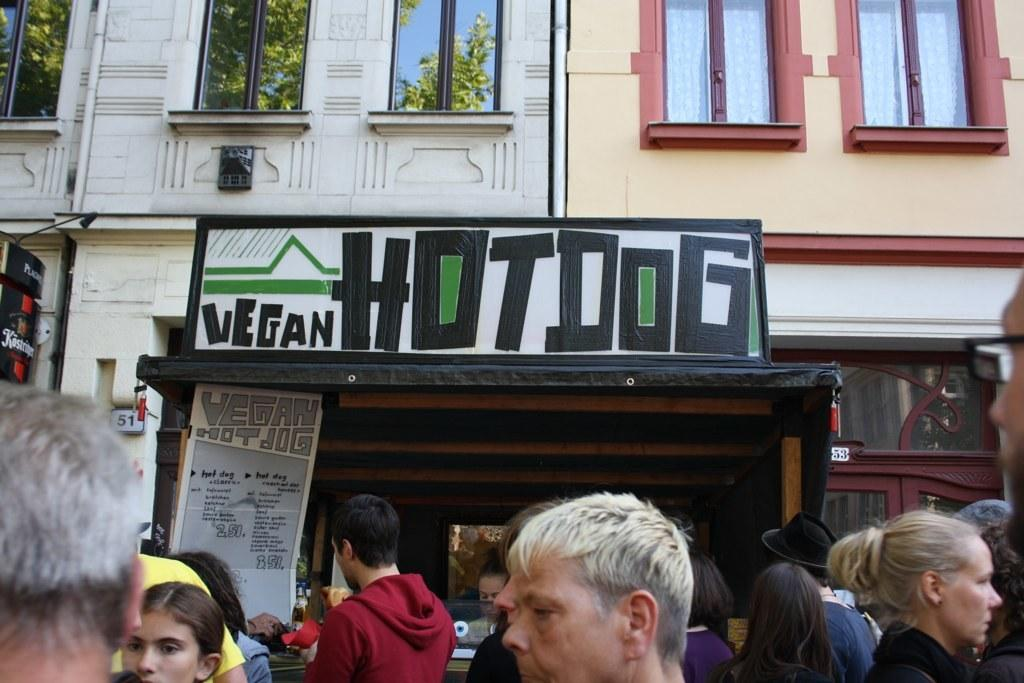What can be seen at the bottom of the image? There are persons at the bottom of the image. What is located in the center of the image? There is a name board for a building in the center of the image. What architectural features can be seen in the background of the image? Windows and buildings are visible in the background of the image. What type of rhythm is being played by the rake in the image? There is no rake present in the image, and therefore no rhythm can be associated with it. What kind of pleasure can be derived from the building in the image? The image does not convey any information about the pleasure derived from the building; it only shows a name board for the building. 